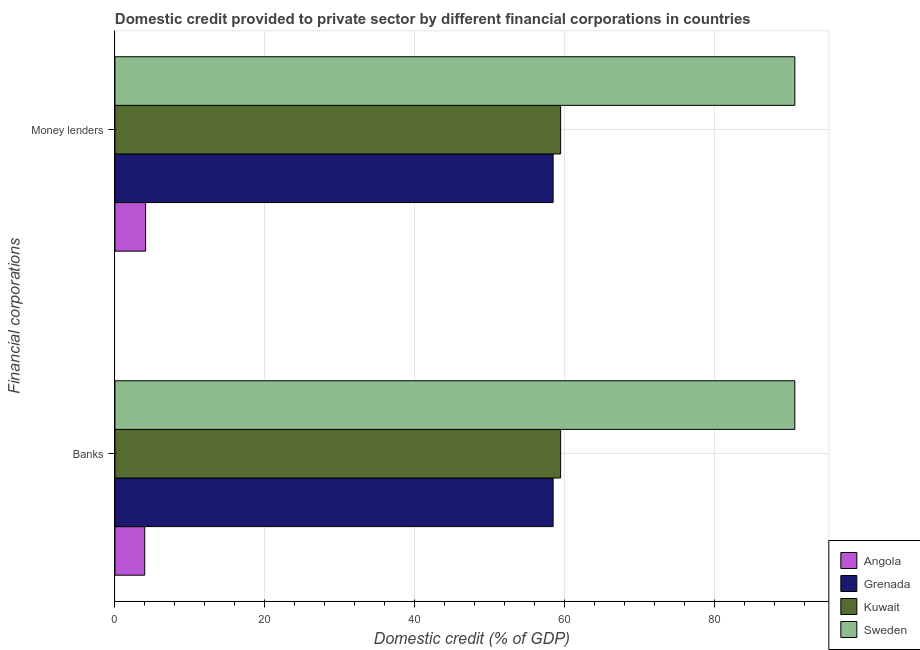Are the number of bars per tick equal to the number of legend labels?
Provide a short and direct response. Yes. Are the number of bars on each tick of the Y-axis equal?
Your answer should be compact. Yes. How many bars are there on the 1st tick from the top?
Your answer should be very brief. 4. How many bars are there on the 2nd tick from the bottom?
Offer a very short reply. 4. What is the label of the 2nd group of bars from the top?
Provide a short and direct response. Banks. What is the domestic credit provided by banks in Sweden?
Ensure brevity in your answer.  90.71. Across all countries, what is the maximum domestic credit provided by money lenders?
Keep it short and to the point. 90.72. Across all countries, what is the minimum domestic credit provided by banks?
Provide a short and direct response. 3.98. In which country was the domestic credit provided by money lenders minimum?
Give a very brief answer. Angola. What is the total domestic credit provided by money lenders in the graph?
Your answer should be very brief. 212.73. What is the difference between the domestic credit provided by banks in Kuwait and that in Grenada?
Give a very brief answer. 1. What is the difference between the domestic credit provided by money lenders in Angola and the domestic credit provided by banks in Sweden?
Your answer should be very brief. -86.63. What is the average domestic credit provided by banks per country?
Offer a terse response. 53.16. In how many countries, is the domestic credit provided by banks greater than 8 %?
Keep it short and to the point. 3. What is the ratio of the domestic credit provided by banks in Sweden to that in Grenada?
Provide a succinct answer. 1.55. In how many countries, is the domestic credit provided by banks greater than the average domestic credit provided by banks taken over all countries?
Your answer should be compact. 3. What does the 3rd bar from the top in Money lenders represents?
Offer a very short reply. Grenada. What does the 3rd bar from the bottom in Money lenders represents?
Your answer should be very brief. Kuwait. Are all the bars in the graph horizontal?
Your answer should be very brief. Yes. What is the difference between two consecutive major ticks on the X-axis?
Offer a terse response. 20. Are the values on the major ticks of X-axis written in scientific E-notation?
Keep it short and to the point. No. Where does the legend appear in the graph?
Offer a very short reply. Bottom right. What is the title of the graph?
Offer a very short reply. Domestic credit provided to private sector by different financial corporations in countries. Does "Philippines" appear as one of the legend labels in the graph?
Your response must be concise. No. What is the label or title of the X-axis?
Your answer should be very brief. Domestic credit (% of GDP). What is the label or title of the Y-axis?
Your answer should be compact. Financial corporations. What is the Domestic credit (% of GDP) of Angola in Banks?
Make the answer very short. 3.98. What is the Domestic credit (% of GDP) of Grenada in Banks?
Offer a terse response. 58.46. What is the Domestic credit (% of GDP) of Kuwait in Banks?
Make the answer very short. 59.47. What is the Domestic credit (% of GDP) of Sweden in Banks?
Provide a succinct answer. 90.71. What is the Domestic credit (% of GDP) of Angola in Money lenders?
Provide a short and direct response. 4.09. What is the Domestic credit (% of GDP) in Grenada in Money lenders?
Provide a succinct answer. 58.46. What is the Domestic credit (% of GDP) of Kuwait in Money lenders?
Provide a succinct answer. 59.47. What is the Domestic credit (% of GDP) of Sweden in Money lenders?
Make the answer very short. 90.72. Across all Financial corporations, what is the maximum Domestic credit (% of GDP) in Angola?
Your answer should be very brief. 4.09. Across all Financial corporations, what is the maximum Domestic credit (% of GDP) of Grenada?
Provide a succinct answer. 58.46. Across all Financial corporations, what is the maximum Domestic credit (% of GDP) of Kuwait?
Your answer should be very brief. 59.47. Across all Financial corporations, what is the maximum Domestic credit (% of GDP) of Sweden?
Your answer should be very brief. 90.72. Across all Financial corporations, what is the minimum Domestic credit (% of GDP) of Angola?
Your answer should be very brief. 3.98. Across all Financial corporations, what is the minimum Domestic credit (% of GDP) in Grenada?
Your answer should be compact. 58.46. Across all Financial corporations, what is the minimum Domestic credit (% of GDP) in Kuwait?
Make the answer very short. 59.47. Across all Financial corporations, what is the minimum Domestic credit (% of GDP) of Sweden?
Make the answer very short. 90.71. What is the total Domestic credit (% of GDP) in Angola in the graph?
Provide a short and direct response. 8.06. What is the total Domestic credit (% of GDP) of Grenada in the graph?
Provide a short and direct response. 116.93. What is the total Domestic credit (% of GDP) of Kuwait in the graph?
Ensure brevity in your answer.  118.93. What is the total Domestic credit (% of GDP) of Sweden in the graph?
Ensure brevity in your answer.  181.43. What is the difference between the Domestic credit (% of GDP) of Angola in Banks and that in Money lenders?
Provide a succinct answer. -0.11. What is the difference between the Domestic credit (% of GDP) in Kuwait in Banks and that in Money lenders?
Offer a very short reply. 0. What is the difference between the Domestic credit (% of GDP) in Sweden in Banks and that in Money lenders?
Give a very brief answer. -0. What is the difference between the Domestic credit (% of GDP) in Angola in Banks and the Domestic credit (% of GDP) in Grenada in Money lenders?
Your response must be concise. -54.49. What is the difference between the Domestic credit (% of GDP) in Angola in Banks and the Domestic credit (% of GDP) in Kuwait in Money lenders?
Your response must be concise. -55.49. What is the difference between the Domestic credit (% of GDP) in Angola in Banks and the Domestic credit (% of GDP) in Sweden in Money lenders?
Your answer should be very brief. -86.74. What is the difference between the Domestic credit (% of GDP) of Grenada in Banks and the Domestic credit (% of GDP) of Kuwait in Money lenders?
Make the answer very short. -1. What is the difference between the Domestic credit (% of GDP) of Grenada in Banks and the Domestic credit (% of GDP) of Sweden in Money lenders?
Give a very brief answer. -32.25. What is the difference between the Domestic credit (% of GDP) of Kuwait in Banks and the Domestic credit (% of GDP) of Sweden in Money lenders?
Offer a very short reply. -31.25. What is the average Domestic credit (% of GDP) of Angola per Financial corporations?
Offer a very short reply. 4.03. What is the average Domestic credit (% of GDP) of Grenada per Financial corporations?
Provide a succinct answer. 58.46. What is the average Domestic credit (% of GDP) of Kuwait per Financial corporations?
Your answer should be very brief. 59.47. What is the average Domestic credit (% of GDP) in Sweden per Financial corporations?
Give a very brief answer. 90.72. What is the difference between the Domestic credit (% of GDP) in Angola and Domestic credit (% of GDP) in Grenada in Banks?
Offer a terse response. -54.49. What is the difference between the Domestic credit (% of GDP) in Angola and Domestic credit (% of GDP) in Kuwait in Banks?
Give a very brief answer. -55.49. What is the difference between the Domestic credit (% of GDP) of Angola and Domestic credit (% of GDP) of Sweden in Banks?
Give a very brief answer. -86.74. What is the difference between the Domestic credit (% of GDP) of Grenada and Domestic credit (% of GDP) of Kuwait in Banks?
Make the answer very short. -1. What is the difference between the Domestic credit (% of GDP) in Grenada and Domestic credit (% of GDP) in Sweden in Banks?
Offer a terse response. -32.25. What is the difference between the Domestic credit (% of GDP) in Kuwait and Domestic credit (% of GDP) in Sweden in Banks?
Keep it short and to the point. -31.25. What is the difference between the Domestic credit (% of GDP) of Angola and Domestic credit (% of GDP) of Grenada in Money lenders?
Offer a terse response. -54.38. What is the difference between the Domestic credit (% of GDP) in Angola and Domestic credit (% of GDP) in Kuwait in Money lenders?
Provide a succinct answer. -55.38. What is the difference between the Domestic credit (% of GDP) in Angola and Domestic credit (% of GDP) in Sweden in Money lenders?
Your response must be concise. -86.63. What is the difference between the Domestic credit (% of GDP) of Grenada and Domestic credit (% of GDP) of Kuwait in Money lenders?
Offer a very short reply. -1. What is the difference between the Domestic credit (% of GDP) in Grenada and Domestic credit (% of GDP) in Sweden in Money lenders?
Make the answer very short. -32.25. What is the difference between the Domestic credit (% of GDP) in Kuwait and Domestic credit (% of GDP) in Sweden in Money lenders?
Give a very brief answer. -31.25. What is the ratio of the Domestic credit (% of GDP) of Angola in Banks to that in Money lenders?
Keep it short and to the point. 0.97. What is the difference between the highest and the second highest Domestic credit (% of GDP) of Angola?
Offer a terse response. 0.11. What is the difference between the highest and the second highest Domestic credit (% of GDP) in Sweden?
Your answer should be compact. 0. What is the difference between the highest and the lowest Domestic credit (% of GDP) in Angola?
Keep it short and to the point. 0.11. What is the difference between the highest and the lowest Domestic credit (% of GDP) in Kuwait?
Provide a succinct answer. 0. What is the difference between the highest and the lowest Domestic credit (% of GDP) of Sweden?
Provide a short and direct response. 0. 